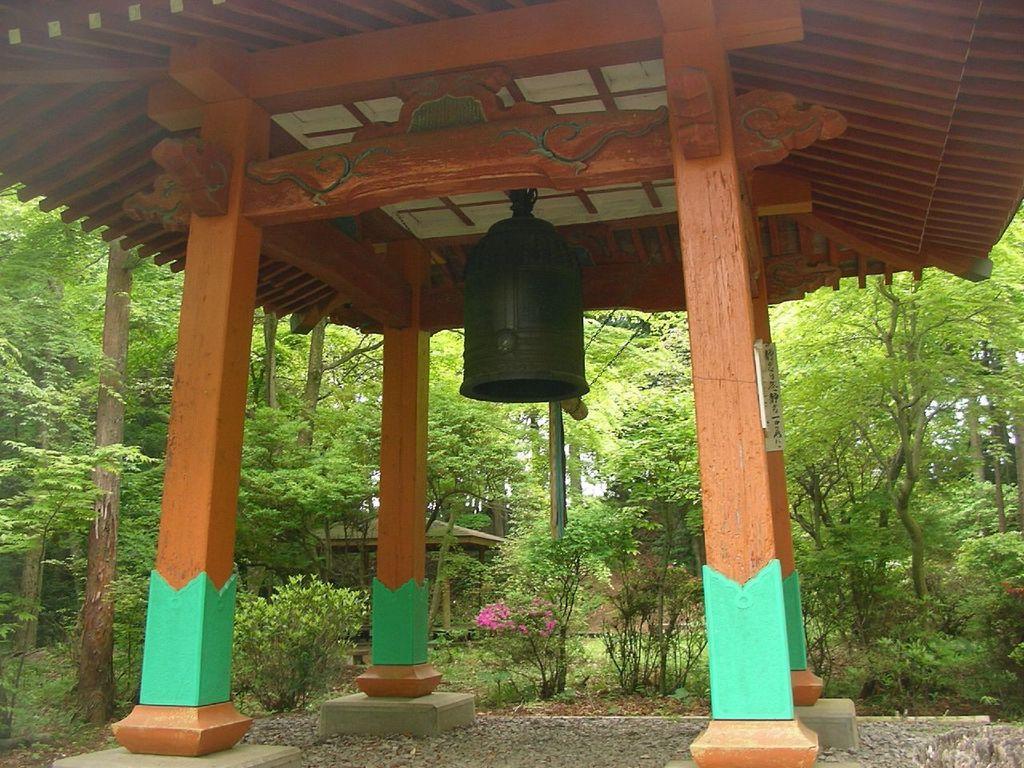In one or two sentences, can you explain what this image depicts? In this image there is a bell hanged from the wooden roof top supported by the wooden pillars. In the background of the image there are plants, trees and there is a wooden shed. 